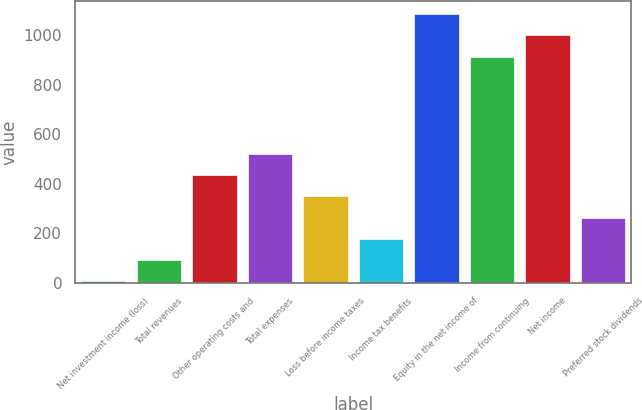<chart> <loc_0><loc_0><loc_500><loc_500><bar_chart><fcel>Net investment income (loss)<fcel>Total revenues<fcel>Other operating costs and<fcel>Total expenses<fcel>Loss before income taxes<fcel>Income tax benefits<fcel>Equity in the net income of<fcel>Income from continuing<fcel>Net income<fcel>Preferred stock dividends<nl><fcel>6.8<fcel>92.53<fcel>435.45<fcel>521.18<fcel>349.72<fcel>178.26<fcel>1084.49<fcel>913.03<fcel>998.76<fcel>263.99<nl></chart> 